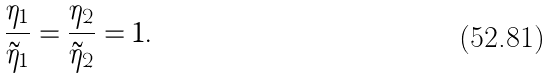Convert formula to latex. <formula><loc_0><loc_0><loc_500><loc_500>\frac { \eta _ { 1 } } { \tilde { \eta } _ { 1 } } = \frac { \eta _ { 2 } } { \tilde { \eta } _ { 2 } } = 1 .</formula> 